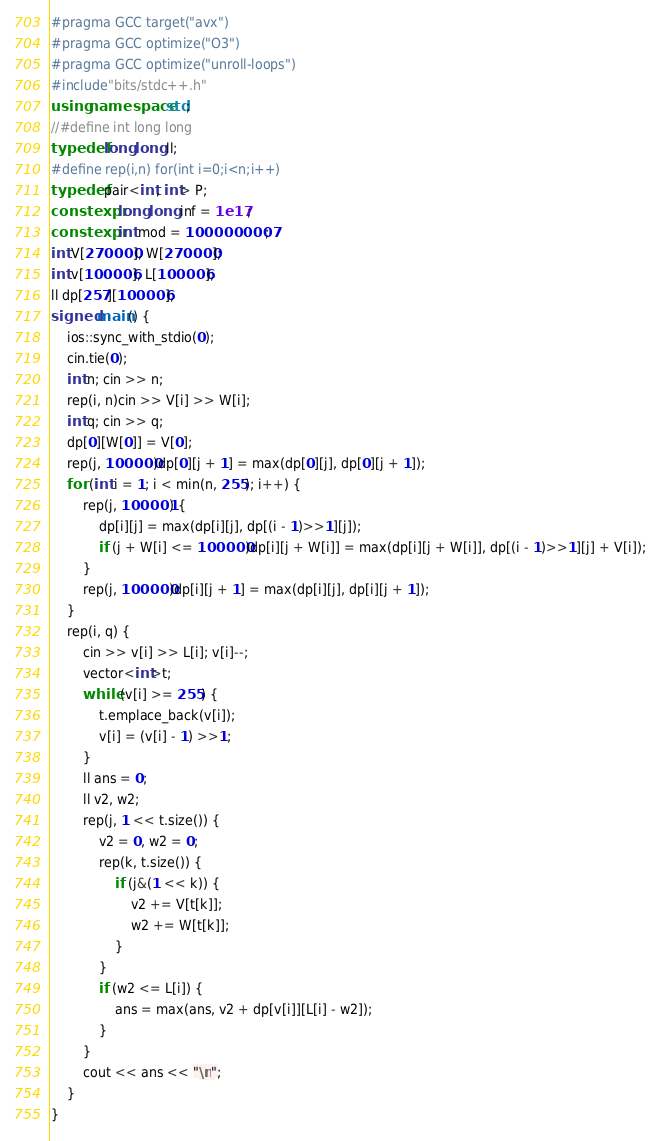<code> <loc_0><loc_0><loc_500><loc_500><_C++_>#pragma GCC target("avx")
#pragma GCC optimize("O3")
#pragma GCC optimize("unroll-loops")
#include"bits/stdc++.h"
using namespace std;
//#define int long long
typedef long long ll;
#define rep(i,n) for(int i=0;i<n;i++)
typedef pair<int, int> P;
constexpr long long inf = 1e17;
constexpr int mod = 1000000007;
int V[270000], W[270000];
int v[100006], L[100006];
ll dp[257][100006];
signed main() {
	ios::sync_with_stdio(0);
	cin.tie(0);
	int n; cin >> n;
	rep(i, n)cin >> V[i] >> W[i];
	int q; cin >> q;
	dp[0][W[0]] = V[0];
	rep(j, 100000)dp[0][j + 1] = max(dp[0][j], dp[0][j + 1]);
	for (int i = 1; i < min(n, 255); i++) {
		rep(j, 100001) {
			dp[i][j] = max(dp[i][j], dp[(i - 1)>>1][j]);
			if (j + W[i] <= 100000)dp[i][j + W[i]] = max(dp[i][j + W[i]], dp[(i - 1)>>1][j] + V[i]);
		}
		rep(j, 100000)dp[i][j + 1] = max(dp[i][j], dp[i][j + 1]);
	}
	rep(i, q) {
		cin >> v[i] >> L[i]; v[i]--;
		vector<int>t;
		while (v[i] >= 255) {
			t.emplace_back(v[i]);
			v[i] = (v[i] - 1) >>1;
		}
		ll ans = 0;
		ll v2, w2;
		rep(j, 1 << t.size()) {
			v2 = 0, w2 = 0;
			rep(k, t.size()) {
				if (j&(1 << k)) {
					v2 += V[t[k]];
					w2 += W[t[k]];
				}
			}
			if (w2 <= L[i]) {
				ans = max(ans, v2 + dp[v[i]][L[i] - w2]);
			}
		}
		cout << ans << "\n";
	}
}</code> 